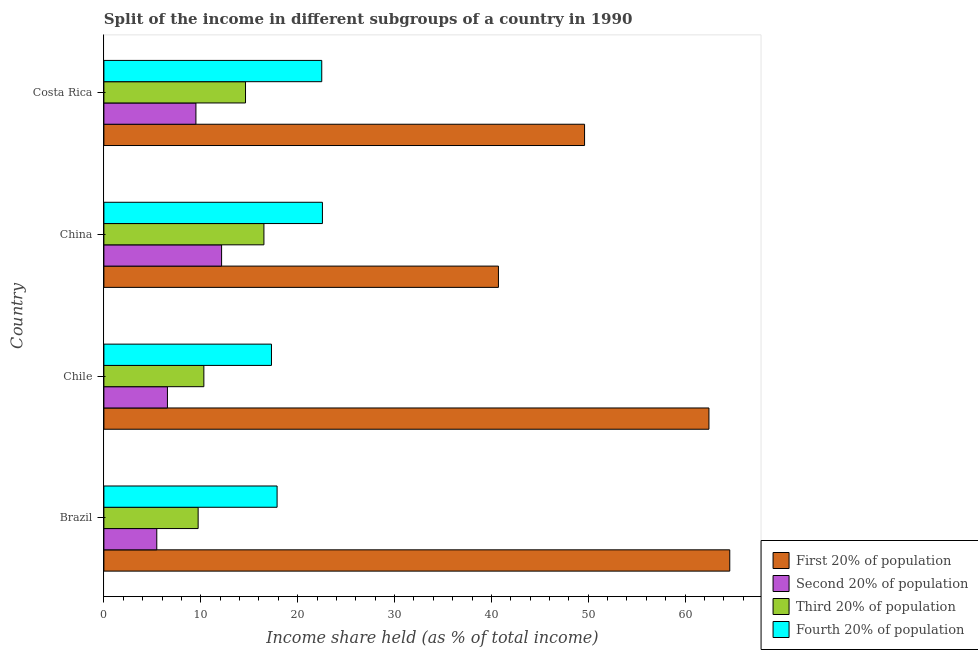How many groups of bars are there?
Keep it short and to the point. 4. Are the number of bars per tick equal to the number of legend labels?
Offer a very short reply. Yes. Are the number of bars on each tick of the Y-axis equal?
Your response must be concise. Yes. How many bars are there on the 1st tick from the top?
Ensure brevity in your answer.  4. How many bars are there on the 1st tick from the bottom?
Your answer should be very brief. 4. What is the label of the 3rd group of bars from the top?
Provide a short and direct response. Chile. In how many cases, is the number of bars for a given country not equal to the number of legend labels?
Provide a short and direct response. 0. What is the share of the income held by fourth 20% of the population in China?
Offer a very short reply. 22.56. Across all countries, what is the maximum share of the income held by second 20% of the population?
Provide a short and direct response. 12.15. Across all countries, what is the minimum share of the income held by fourth 20% of the population?
Provide a short and direct response. 17.3. In which country was the share of the income held by fourth 20% of the population maximum?
Make the answer very short. China. In which country was the share of the income held by third 20% of the population minimum?
Provide a short and direct response. Brazil. What is the total share of the income held by first 20% of the population in the graph?
Offer a terse response. 217.42. What is the difference between the share of the income held by second 20% of the population in Brazil and that in China?
Make the answer very short. -6.69. What is the difference between the share of the income held by second 20% of the population in Costa Rica and the share of the income held by fourth 20% of the population in Chile?
Provide a short and direct response. -7.8. What is the average share of the income held by third 20% of the population per country?
Provide a short and direct response. 12.8. What is the difference between the share of the income held by third 20% of the population and share of the income held by first 20% of the population in Chile?
Your response must be concise. -52.14. What is the ratio of the share of the income held by fourth 20% of the population in Brazil to that in Chile?
Offer a terse response. 1.03. Is the share of the income held by first 20% of the population in Chile less than that in Costa Rica?
Make the answer very short. No. Is the difference between the share of the income held by second 20% of the population in China and Costa Rica greater than the difference between the share of the income held by fourth 20% of the population in China and Costa Rica?
Your answer should be very brief. Yes. What is the difference between the highest and the second highest share of the income held by fourth 20% of the population?
Give a very brief answer. 0.07. What is the difference between the highest and the lowest share of the income held by second 20% of the population?
Offer a terse response. 6.69. In how many countries, is the share of the income held by first 20% of the population greater than the average share of the income held by first 20% of the population taken over all countries?
Your answer should be very brief. 2. Is the sum of the share of the income held by second 20% of the population in China and Costa Rica greater than the maximum share of the income held by third 20% of the population across all countries?
Keep it short and to the point. Yes. What does the 3rd bar from the top in Brazil represents?
Ensure brevity in your answer.  Second 20% of population. What does the 2nd bar from the bottom in China represents?
Your answer should be very brief. Second 20% of population. Is it the case that in every country, the sum of the share of the income held by first 20% of the population and share of the income held by second 20% of the population is greater than the share of the income held by third 20% of the population?
Ensure brevity in your answer.  Yes. Are all the bars in the graph horizontal?
Offer a very short reply. Yes. How many countries are there in the graph?
Give a very brief answer. 4. What is the difference between two consecutive major ticks on the X-axis?
Offer a very short reply. 10. Does the graph contain any zero values?
Offer a terse response. No. Where does the legend appear in the graph?
Offer a terse response. Bottom right. What is the title of the graph?
Offer a very short reply. Split of the income in different subgroups of a country in 1990. What is the label or title of the X-axis?
Your answer should be very brief. Income share held (as % of total income). What is the label or title of the Y-axis?
Offer a terse response. Country. What is the Income share held (as % of total income) in First 20% of population in Brazil?
Provide a succinct answer. 64.61. What is the Income share held (as % of total income) in Second 20% of population in Brazil?
Offer a very short reply. 5.46. What is the Income share held (as % of total income) of Third 20% of population in Brazil?
Keep it short and to the point. 9.73. What is the Income share held (as % of total income) of Fourth 20% of population in Brazil?
Provide a short and direct response. 17.88. What is the Income share held (as % of total income) in First 20% of population in Chile?
Ensure brevity in your answer.  62.46. What is the Income share held (as % of total income) in Second 20% of population in Chile?
Make the answer very short. 6.56. What is the Income share held (as % of total income) of Third 20% of population in Chile?
Provide a short and direct response. 10.32. What is the Income share held (as % of total income) of First 20% of population in China?
Your answer should be compact. 40.73. What is the Income share held (as % of total income) of Second 20% of population in China?
Keep it short and to the point. 12.15. What is the Income share held (as % of total income) in Third 20% of population in China?
Your answer should be very brief. 16.52. What is the Income share held (as % of total income) of Fourth 20% of population in China?
Provide a succinct answer. 22.56. What is the Income share held (as % of total income) of First 20% of population in Costa Rica?
Offer a very short reply. 49.62. What is the Income share held (as % of total income) of Second 20% of population in Costa Rica?
Your response must be concise. 9.5. What is the Income share held (as % of total income) of Third 20% of population in Costa Rica?
Ensure brevity in your answer.  14.62. What is the Income share held (as % of total income) of Fourth 20% of population in Costa Rica?
Keep it short and to the point. 22.49. Across all countries, what is the maximum Income share held (as % of total income) in First 20% of population?
Ensure brevity in your answer.  64.61. Across all countries, what is the maximum Income share held (as % of total income) of Second 20% of population?
Offer a terse response. 12.15. Across all countries, what is the maximum Income share held (as % of total income) of Third 20% of population?
Keep it short and to the point. 16.52. Across all countries, what is the maximum Income share held (as % of total income) in Fourth 20% of population?
Your response must be concise. 22.56. Across all countries, what is the minimum Income share held (as % of total income) of First 20% of population?
Ensure brevity in your answer.  40.73. Across all countries, what is the minimum Income share held (as % of total income) in Second 20% of population?
Your answer should be compact. 5.46. Across all countries, what is the minimum Income share held (as % of total income) in Third 20% of population?
Ensure brevity in your answer.  9.73. What is the total Income share held (as % of total income) in First 20% of population in the graph?
Provide a succinct answer. 217.42. What is the total Income share held (as % of total income) of Second 20% of population in the graph?
Provide a short and direct response. 33.67. What is the total Income share held (as % of total income) in Third 20% of population in the graph?
Keep it short and to the point. 51.19. What is the total Income share held (as % of total income) of Fourth 20% of population in the graph?
Your answer should be very brief. 80.23. What is the difference between the Income share held (as % of total income) of First 20% of population in Brazil and that in Chile?
Provide a short and direct response. 2.15. What is the difference between the Income share held (as % of total income) in Third 20% of population in Brazil and that in Chile?
Give a very brief answer. -0.59. What is the difference between the Income share held (as % of total income) in Fourth 20% of population in Brazil and that in Chile?
Offer a very short reply. 0.58. What is the difference between the Income share held (as % of total income) of First 20% of population in Brazil and that in China?
Offer a very short reply. 23.88. What is the difference between the Income share held (as % of total income) in Second 20% of population in Brazil and that in China?
Offer a terse response. -6.69. What is the difference between the Income share held (as % of total income) of Third 20% of population in Brazil and that in China?
Offer a very short reply. -6.79. What is the difference between the Income share held (as % of total income) of Fourth 20% of population in Brazil and that in China?
Offer a very short reply. -4.68. What is the difference between the Income share held (as % of total income) in First 20% of population in Brazil and that in Costa Rica?
Make the answer very short. 14.99. What is the difference between the Income share held (as % of total income) of Second 20% of population in Brazil and that in Costa Rica?
Offer a terse response. -4.04. What is the difference between the Income share held (as % of total income) of Third 20% of population in Brazil and that in Costa Rica?
Give a very brief answer. -4.89. What is the difference between the Income share held (as % of total income) in Fourth 20% of population in Brazil and that in Costa Rica?
Offer a terse response. -4.61. What is the difference between the Income share held (as % of total income) of First 20% of population in Chile and that in China?
Keep it short and to the point. 21.73. What is the difference between the Income share held (as % of total income) of Second 20% of population in Chile and that in China?
Your answer should be very brief. -5.59. What is the difference between the Income share held (as % of total income) in Fourth 20% of population in Chile and that in China?
Ensure brevity in your answer.  -5.26. What is the difference between the Income share held (as % of total income) of First 20% of population in Chile and that in Costa Rica?
Keep it short and to the point. 12.84. What is the difference between the Income share held (as % of total income) of Second 20% of population in Chile and that in Costa Rica?
Provide a short and direct response. -2.94. What is the difference between the Income share held (as % of total income) in Third 20% of population in Chile and that in Costa Rica?
Offer a terse response. -4.3. What is the difference between the Income share held (as % of total income) of Fourth 20% of population in Chile and that in Costa Rica?
Your answer should be compact. -5.19. What is the difference between the Income share held (as % of total income) in First 20% of population in China and that in Costa Rica?
Make the answer very short. -8.89. What is the difference between the Income share held (as % of total income) in Second 20% of population in China and that in Costa Rica?
Provide a short and direct response. 2.65. What is the difference between the Income share held (as % of total income) of Third 20% of population in China and that in Costa Rica?
Keep it short and to the point. 1.9. What is the difference between the Income share held (as % of total income) in Fourth 20% of population in China and that in Costa Rica?
Offer a very short reply. 0.07. What is the difference between the Income share held (as % of total income) of First 20% of population in Brazil and the Income share held (as % of total income) of Second 20% of population in Chile?
Provide a succinct answer. 58.05. What is the difference between the Income share held (as % of total income) of First 20% of population in Brazil and the Income share held (as % of total income) of Third 20% of population in Chile?
Make the answer very short. 54.29. What is the difference between the Income share held (as % of total income) in First 20% of population in Brazil and the Income share held (as % of total income) in Fourth 20% of population in Chile?
Give a very brief answer. 47.31. What is the difference between the Income share held (as % of total income) in Second 20% of population in Brazil and the Income share held (as % of total income) in Third 20% of population in Chile?
Provide a succinct answer. -4.86. What is the difference between the Income share held (as % of total income) of Second 20% of population in Brazil and the Income share held (as % of total income) of Fourth 20% of population in Chile?
Your answer should be very brief. -11.84. What is the difference between the Income share held (as % of total income) in Third 20% of population in Brazil and the Income share held (as % of total income) in Fourth 20% of population in Chile?
Provide a short and direct response. -7.57. What is the difference between the Income share held (as % of total income) in First 20% of population in Brazil and the Income share held (as % of total income) in Second 20% of population in China?
Ensure brevity in your answer.  52.46. What is the difference between the Income share held (as % of total income) in First 20% of population in Brazil and the Income share held (as % of total income) in Third 20% of population in China?
Your answer should be very brief. 48.09. What is the difference between the Income share held (as % of total income) of First 20% of population in Brazil and the Income share held (as % of total income) of Fourth 20% of population in China?
Ensure brevity in your answer.  42.05. What is the difference between the Income share held (as % of total income) of Second 20% of population in Brazil and the Income share held (as % of total income) of Third 20% of population in China?
Ensure brevity in your answer.  -11.06. What is the difference between the Income share held (as % of total income) in Second 20% of population in Brazil and the Income share held (as % of total income) in Fourth 20% of population in China?
Offer a very short reply. -17.1. What is the difference between the Income share held (as % of total income) of Third 20% of population in Brazil and the Income share held (as % of total income) of Fourth 20% of population in China?
Offer a terse response. -12.83. What is the difference between the Income share held (as % of total income) of First 20% of population in Brazil and the Income share held (as % of total income) of Second 20% of population in Costa Rica?
Keep it short and to the point. 55.11. What is the difference between the Income share held (as % of total income) in First 20% of population in Brazil and the Income share held (as % of total income) in Third 20% of population in Costa Rica?
Your answer should be compact. 49.99. What is the difference between the Income share held (as % of total income) of First 20% of population in Brazil and the Income share held (as % of total income) of Fourth 20% of population in Costa Rica?
Offer a terse response. 42.12. What is the difference between the Income share held (as % of total income) of Second 20% of population in Brazil and the Income share held (as % of total income) of Third 20% of population in Costa Rica?
Give a very brief answer. -9.16. What is the difference between the Income share held (as % of total income) in Second 20% of population in Brazil and the Income share held (as % of total income) in Fourth 20% of population in Costa Rica?
Offer a very short reply. -17.03. What is the difference between the Income share held (as % of total income) in Third 20% of population in Brazil and the Income share held (as % of total income) in Fourth 20% of population in Costa Rica?
Offer a very short reply. -12.76. What is the difference between the Income share held (as % of total income) in First 20% of population in Chile and the Income share held (as % of total income) in Second 20% of population in China?
Your answer should be compact. 50.31. What is the difference between the Income share held (as % of total income) of First 20% of population in Chile and the Income share held (as % of total income) of Third 20% of population in China?
Provide a short and direct response. 45.94. What is the difference between the Income share held (as % of total income) in First 20% of population in Chile and the Income share held (as % of total income) in Fourth 20% of population in China?
Your response must be concise. 39.9. What is the difference between the Income share held (as % of total income) of Second 20% of population in Chile and the Income share held (as % of total income) of Third 20% of population in China?
Provide a succinct answer. -9.96. What is the difference between the Income share held (as % of total income) in Second 20% of population in Chile and the Income share held (as % of total income) in Fourth 20% of population in China?
Offer a very short reply. -16. What is the difference between the Income share held (as % of total income) of Third 20% of population in Chile and the Income share held (as % of total income) of Fourth 20% of population in China?
Your response must be concise. -12.24. What is the difference between the Income share held (as % of total income) in First 20% of population in Chile and the Income share held (as % of total income) in Second 20% of population in Costa Rica?
Offer a terse response. 52.96. What is the difference between the Income share held (as % of total income) in First 20% of population in Chile and the Income share held (as % of total income) in Third 20% of population in Costa Rica?
Keep it short and to the point. 47.84. What is the difference between the Income share held (as % of total income) in First 20% of population in Chile and the Income share held (as % of total income) in Fourth 20% of population in Costa Rica?
Keep it short and to the point. 39.97. What is the difference between the Income share held (as % of total income) of Second 20% of population in Chile and the Income share held (as % of total income) of Third 20% of population in Costa Rica?
Your response must be concise. -8.06. What is the difference between the Income share held (as % of total income) in Second 20% of population in Chile and the Income share held (as % of total income) in Fourth 20% of population in Costa Rica?
Your answer should be very brief. -15.93. What is the difference between the Income share held (as % of total income) in Third 20% of population in Chile and the Income share held (as % of total income) in Fourth 20% of population in Costa Rica?
Provide a succinct answer. -12.17. What is the difference between the Income share held (as % of total income) in First 20% of population in China and the Income share held (as % of total income) in Second 20% of population in Costa Rica?
Keep it short and to the point. 31.23. What is the difference between the Income share held (as % of total income) in First 20% of population in China and the Income share held (as % of total income) in Third 20% of population in Costa Rica?
Give a very brief answer. 26.11. What is the difference between the Income share held (as % of total income) in First 20% of population in China and the Income share held (as % of total income) in Fourth 20% of population in Costa Rica?
Make the answer very short. 18.24. What is the difference between the Income share held (as % of total income) of Second 20% of population in China and the Income share held (as % of total income) of Third 20% of population in Costa Rica?
Keep it short and to the point. -2.47. What is the difference between the Income share held (as % of total income) of Second 20% of population in China and the Income share held (as % of total income) of Fourth 20% of population in Costa Rica?
Offer a very short reply. -10.34. What is the difference between the Income share held (as % of total income) of Third 20% of population in China and the Income share held (as % of total income) of Fourth 20% of population in Costa Rica?
Keep it short and to the point. -5.97. What is the average Income share held (as % of total income) in First 20% of population per country?
Your response must be concise. 54.35. What is the average Income share held (as % of total income) of Second 20% of population per country?
Keep it short and to the point. 8.42. What is the average Income share held (as % of total income) of Third 20% of population per country?
Offer a terse response. 12.8. What is the average Income share held (as % of total income) in Fourth 20% of population per country?
Offer a terse response. 20.06. What is the difference between the Income share held (as % of total income) in First 20% of population and Income share held (as % of total income) in Second 20% of population in Brazil?
Your answer should be very brief. 59.15. What is the difference between the Income share held (as % of total income) in First 20% of population and Income share held (as % of total income) in Third 20% of population in Brazil?
Keep it short and to the point. 54.88. What is the difference between the Income share held (as % of total income) of First 20% of population and Income share held (as % of total income) of Fourth 20% of population in Brazil?
Provide a short and direct response. 46.73. What is the difference between the Income share held (as % of total income) in Second 20% of population and Income share held (as % of total income) in Third 20% of population in Brazil?
Give a very brief answer. -4.27. What is the difference between the Income share held (as % of total income) of Second 20% of population and Income share held (as % of total income) of Fourth 20% of population in Brazil?
Keep it short and to the point. -12.42. What is the difference between the Income share held (as % of total income) of Third 20% of population and Income share held (as % of total income) of Fourth 20% of population in Brazil?
Offer a very short reply. -8.15. What is the difference between the Income share held (as % of total income) of First 20% of population and Income share held (as % of total income) of Second 20% of population in Chile?
Your answer should be compact. 55.9. What is the difference between the Income share held (as % of total income) in First 20% of population and Income share held (as % of total income) in Third 20% of population in Chile?
Offer a terse response. 52.14. What is the difference between the Income share held (as % of total income) in First 20% of population and Income share held (as % of total income) in Fourth 20% of population in Chile?
Your answer should be very brief. 45.16. What is the difference between the Income share held (as % of total income) of Second 20% of population and Income share held (as % of total income) of Third 20% of population in Chile?
Offer a very short reply. -3.76. What is the difference between the Income share held (as % of total income) of Second 20% of population and Income share held (as % of total income) of Fourth 20% of population in Chile?
Offer a terse response. -10.74. What is the difference between the Income share held (as % of total income) of Third 20% of population and Income share held (as % of total income) of Fourth 20% of population in Chile?
Give a very brief answer. -6.98. What is the difference between the Income share held (as % of total income) in First 20% of population and Income share held (as % of total income) in Second 20% of population in China?
Ensure brevity in your answer.  28.58. What is the difference between the Income share held (as % of total income) in First 20% of population and Income share held (as % of total income) in Third 20% of population in China?
Keep it short and to the point. 24.21. What is the difference between the Income share held (as % of total income) of First 20% of population and Income share held (as % of total income) of Fourth 20% of population in China?
Provide a short and direct response. 18.17. What is the difference between the Income share held (as % of total income) of Second 20% of population and Income share held (as % of total income) of Third 20% of population in China?
Your answer should be very brief. -4.37. What is the difference between the Income share held (as % of total income) of Second 20% of population and Income share held (as % of total income) of Fourth 20% of population in China?
Your answer should be compact. -10.41. What is the difference between the Income share held (as % of total income) in Third 20% of population and Income share held (as % of total income) in Fourth 20% of population in China?
Provide a short and direct response. -6.04. What is the difference between the Income share held (as % of total income) in First 20% of population and Income share held (as % of total income) in Second 20% of population in Costa Rica?
Make the answer very short. 40.12. What is the difference between the Income share held (as % of total income) in First 20% of population and Income share held (as % of total income) in Third 20% of population in Costa Rica?
Give a very brief answer. 35. What is the difference between the Income share held (as % of total income) in First 20% of population and Income share held (as % of total income) in Fourth 20% of population in Costa Rica?
Provide a short and direct response. 27.13. What is the difference between the Income share held (as % of total income) in Second 20% of population and Income share held (as % of total income) in Third 20% of population in Costa Rica?
Ensure brevity in your answer.  -5.12. What is the difference between the Income share held (as % of total income) in Second 20% of population and Income share held (as % of total income) in Fourth 20% of population in Costa Rica?
Make the answer very short. -12.99. What is the difference between the Income share held (as % of total income) of Third 20% of population and Income share held (as % of total income) of Fourth 20% of population in Costa Rica?
Provide a succinct answer. -7.87. What is the ratio of the Income share held (as % of total income) of First 20% of population in Brazil to that in Chile?
Make the answer very short. 1.03. What is the ratio of the Income share held (as % of total income) of Second 20% of population in Brazil to that in Chile?
Your answer should be compact. 0.83. What is the ratio of the Income share held (as % of total income) of Third 20% of population in Brazil to that in Chile?
Ensure brevity in your answer.  0.94. What is the ratio of the Income share held (as % of total income) of Fourth 20% of population in Brazil to that in Chile?
Provide a short and direct response. 1.03. What is the ratio of the Income share held (as % of total income) of First 20% of population in Brazil to that in China?
Offer a very short reply. 1.59. What is the ratio of the Income share held (as % of total income) in Second 20% of population in Brazil to that in China?
Give a very brief answer. 0.45. What is the ratio of the Income share held (as % of total income) of Third 20% of population in Brazil to that in China?
Your response must be concise. 0.59. What is the ratio of the Income share held (as % of total income) of Fourth 20% of population in Brazil to that in China?
Your answer should be very brief. 0.79. What is the ratio of the Income share held (as % of total income) in First 20% of population in Brazil to that in Costa Rica?
Your answer should be very brief. 1.3. What is the ratio of the Income share held (as % of total income) in Second 20% of population in Brazil to that in Costa Rica?
Provide a succinct answer. 0.57. What is the ratio of the Income share held (as % of total income) in Third 20% of population in Brazil to that in Costa Rica?
Offer a terse response. 0.67. What is the ratio of the Income share held (as % of total income) in Fourth 20% of population in Brazil to that in Costa Rica?
Ensure brevity in your answer.  0.8. What is the ratio of the Income share held (as % of total income) in First 20% of population in Chile to that in China?
Provide a succinct answer. 1.53. What is the ratio of the Income share held (as % of total income) of Second 20% of population in Chile to that in China?
Your response must be concise. 0.54. What is the ratio of the Income share held (as % of total income) of Third 20% of population in Chile to that in China?
Your answer should be compact. 0.62. What is the ratio of the Income share held (as % of total income) of Fourth 20% of population in Chile to that in China?
Your answer should be very brief. 0.77. What is the ratio of the Income share held (as % of total income) in First 20% of population in Chile to that in Costa Rica?
Provide a short and direct response. 1.26. What is the ratio of the Income share held (as % of total income) of Second 20% of population in Chile to that in Costa Rica?
Offer a terse response. 0.69. What is the ratio of the Income share held (as % of total income) of Third 20% of population in Chile to that in Costa Rica?
Make the answer very short. 0.71. What is the ratio of the Income share held (as % of total income) of Fourth 20% of population in Chile to that in Costa Rica?
Your response must be concise. 0.77. What is the ratio of the Income share held (as % of total income) of First 20% of population in China to that in Costa Rica?
Make the answer very short. 0.82. What is the ratio of the Income share held (as % of total income) of Second 20% of population in China to that in Costa Rica?
Ensure brevity in your answer.  1.28. What is the ratio of the Income share held (as % of total income) in Third 20% of population in China to that in Costa Rica?
Offer a very short reply. 1.13. What is the difference between the highest and the second highest Income share held (as % of total income) of First 20% of population?
Provide a succinct answer. 2.15. What is the difference between the highest and the second highest Income share held (as % of total income) of Second 20% of population?
Provide a short and direct response. 2.65. What is the difference between the highest and the second highest Income share held (as % of total income) of Fourth 20% of population?
Provide a succinct answer. 0.07. What is the difference between the highest and the lowest Income share held (as % of total income) of First 20% of population?
Your answer should be compact. 23.88. What is the difference between the highest and the lowest Income share held (as % of total income) in Second 20% of population?
Keep it short and to the point. 6.69. What is the difference between the highest and the lowest Income share held (as % of total income) of Third 20% of population?
Your answer should be very brief. 6.79. What is the difference between the highest and the lowest Income share held (as % of total income) in Fourth 20% of population?
Your answer should be very brief. 5.26. 